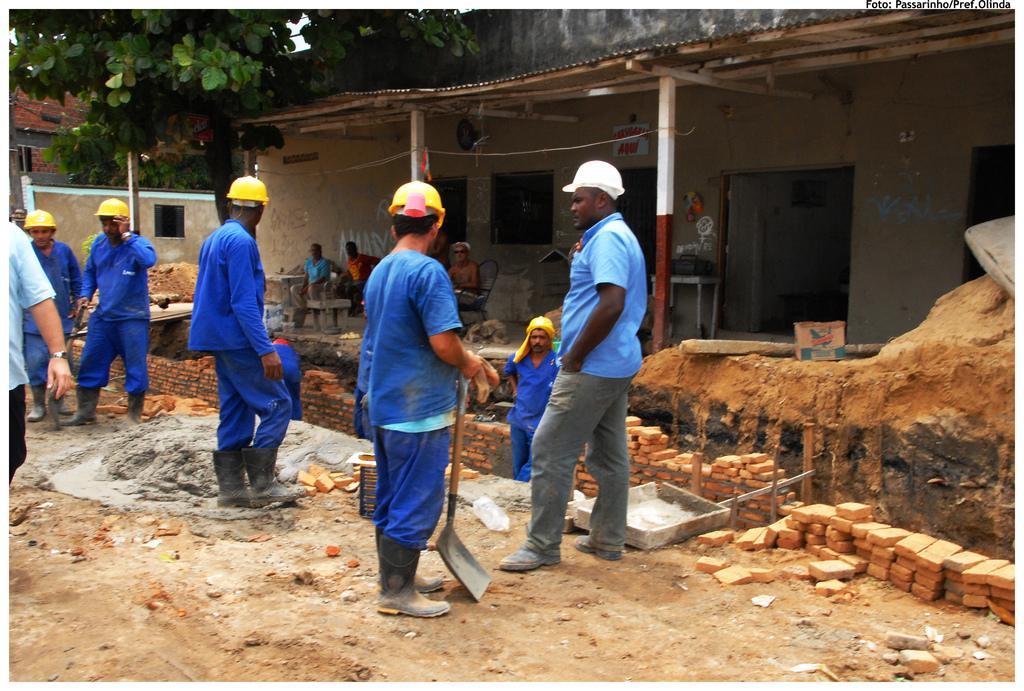In one or two sentences, can you explain what this image depicts? This image is taken outdoors. At the bottom of the image there is a ground. In the background there are two houses with walls, windows, doors and roofs and there is a tree. A few people are sitting on the chairs and a few are standing on the ground. In the middle of the image a man is standing on the ground and he is holding a spade in his hands and there is a cement mixture on the ground and there are a few bricks. 